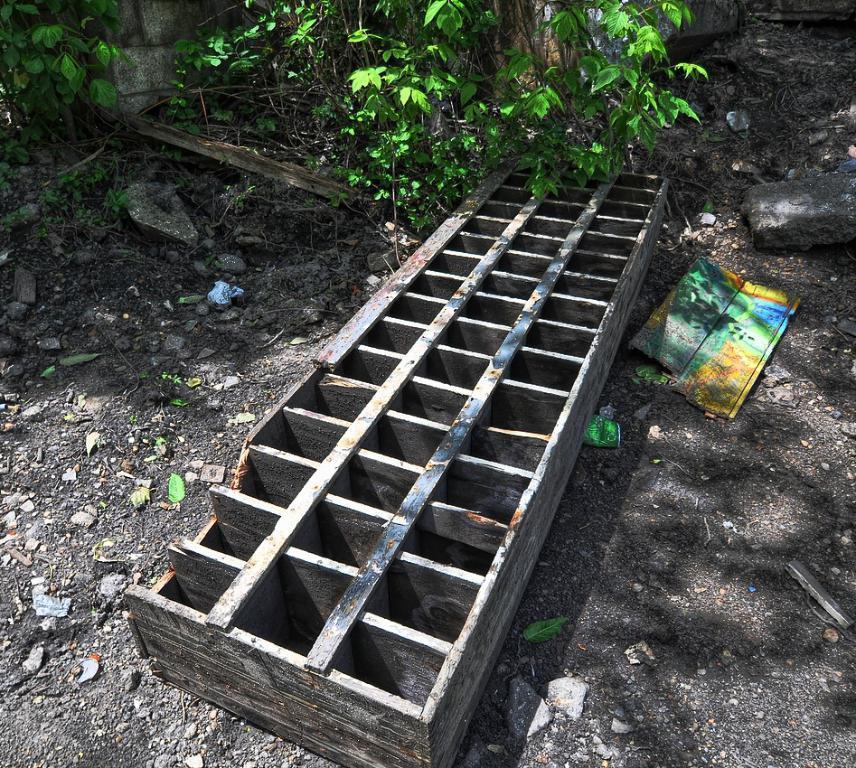How would you summarize this image in a sentence or two? In this image, I can see a wooden object, rocks and there are few other objects on the ground. In the background, there are plants. 